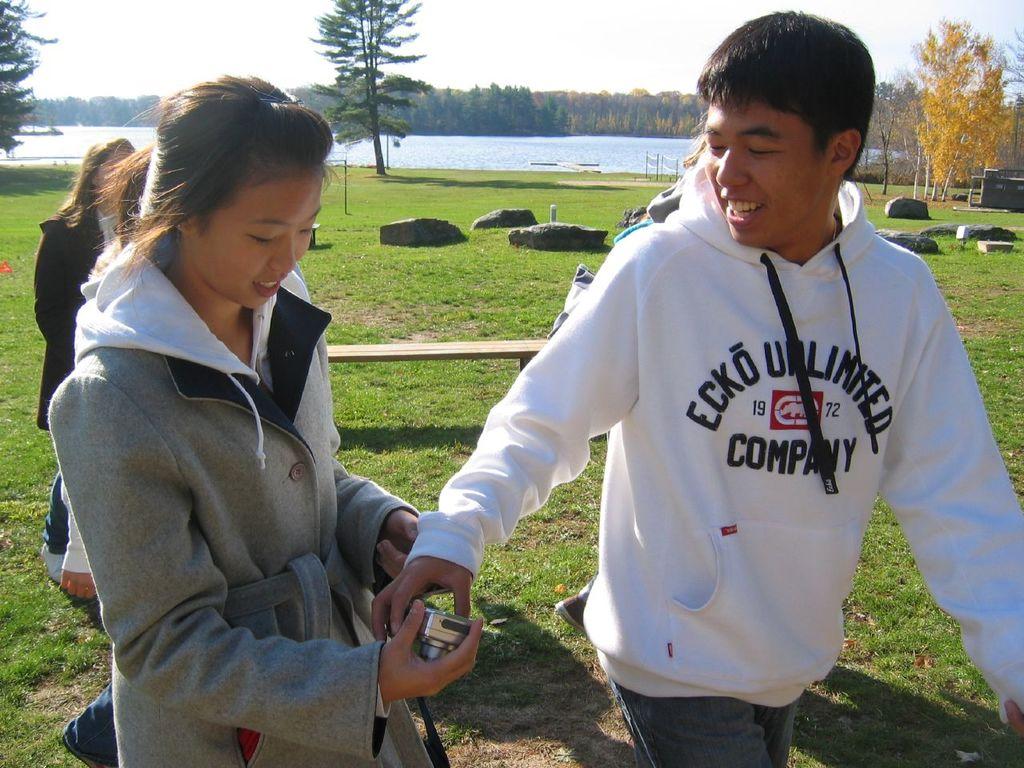What brand sweatshirt is that?
Offer a very short reply. Ecko unlimited. What year is shown on the sweatshirt?
Offer a very short reply. 1972. 